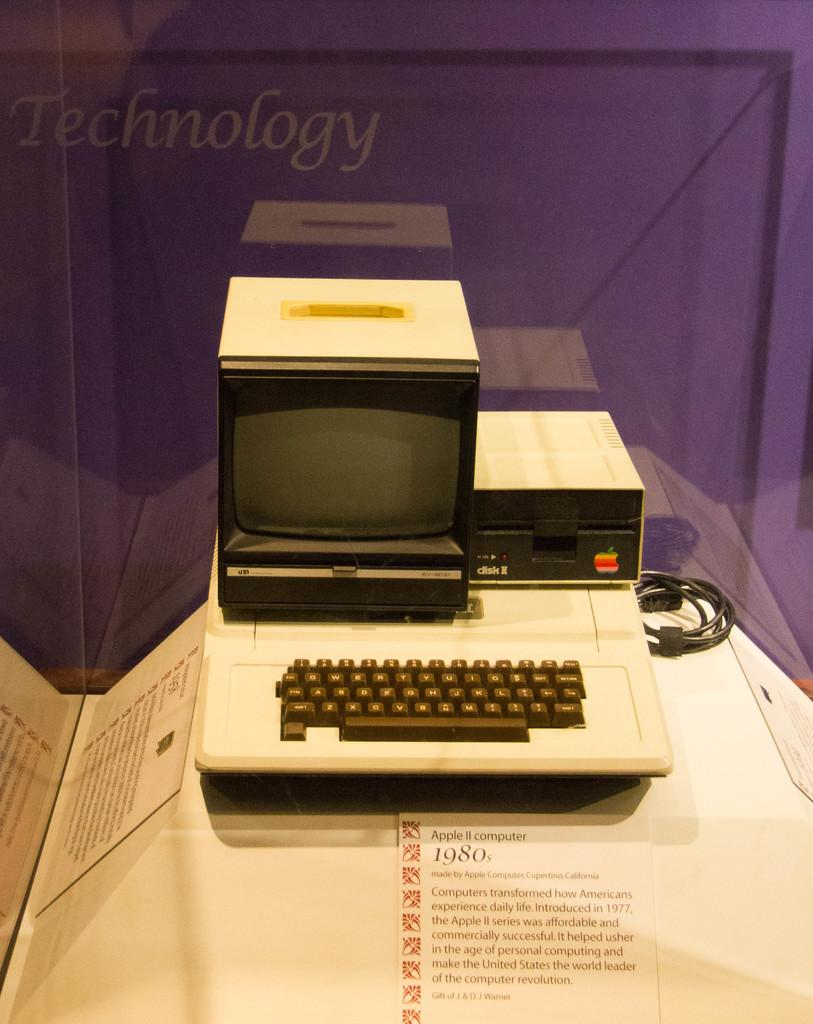<image>
Summarize the visual content of the image. an old APPLE 2 computer from the 1980's with a purple background that says Technology on it. 